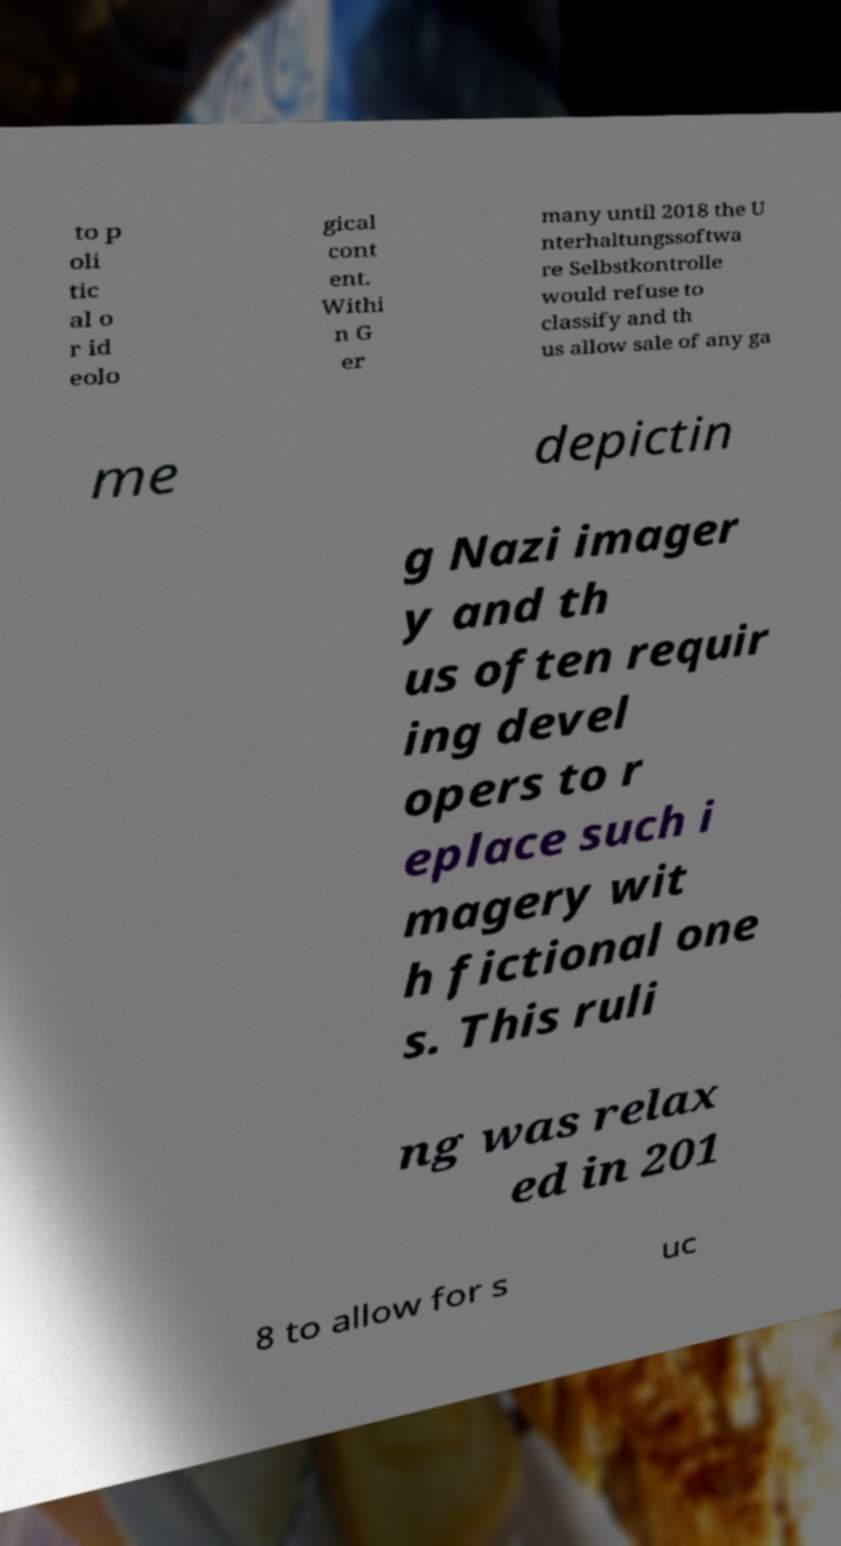Could you assist in decoding the text presented in this image and type it out clearly? to p oli tic al o r id eolo gical cont ent. Withi n G er many until 2018 the U nterhaltungssoftwa re Selbstkontrolle would refuse to classify and th us allow sale of any ga me depictin g Nazi imager y and th us often requir ing devel opers to r eplace such i magery wit h fictional one s. This ruli ng was relax ed in 201 8 to allow for s uc 